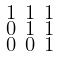Convert formula to latex. <formula><loc_0><loc_0><loc_500><loc_500>\begin{smallmatrix} 1 & 1 & 1 \\ 0 & 1 & 1 \\ 0 & 0 & 1 \\ \end{smallmatrix}</formula> 